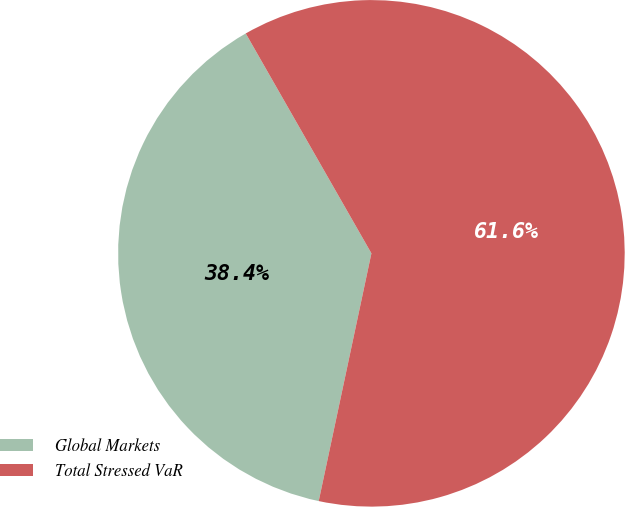Convert chart. <chart><loc_0><loc_0><loc_500><loc_500><pie_chart><fcel>Global Markets<fcel>Total Stressed VaR<nl><fcel>38.4%<fcel>61.6%<nl></chart> 